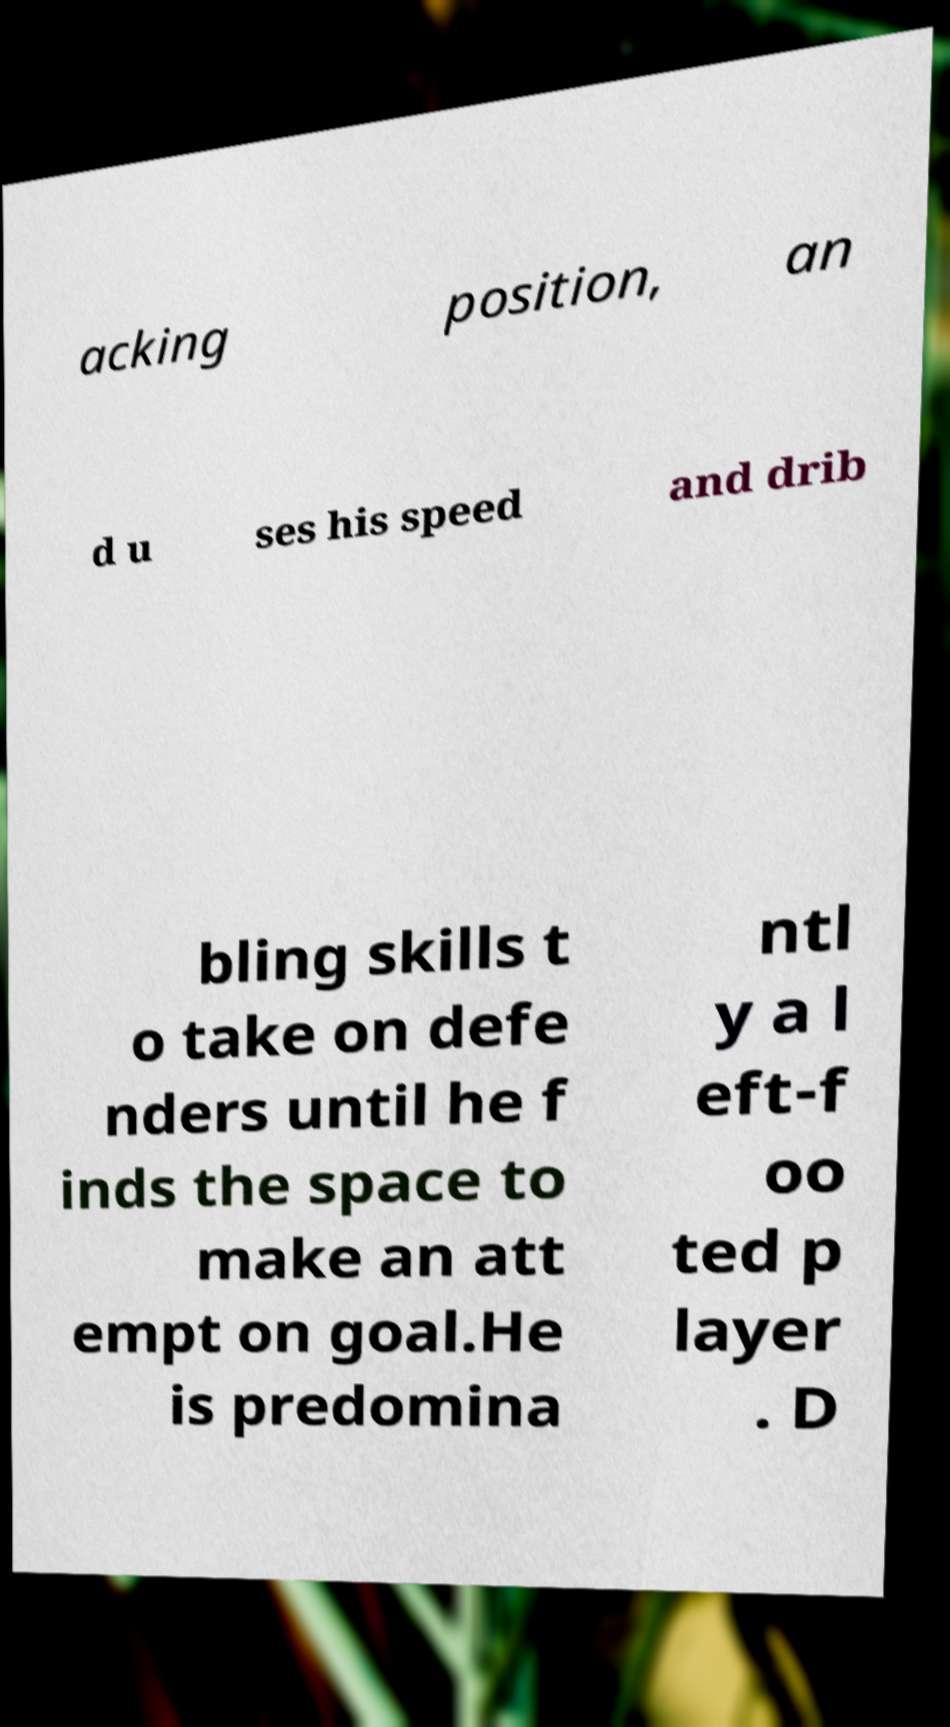For documentation purposes, I need the text within this image transcribed. Could you provide that? acking position, an d u ses his speed and drib bling skills t o take on defe nders until he f inds the space to make an att empt on goal.He is predomina ntl y a l eft-f oo ted p layer . D 